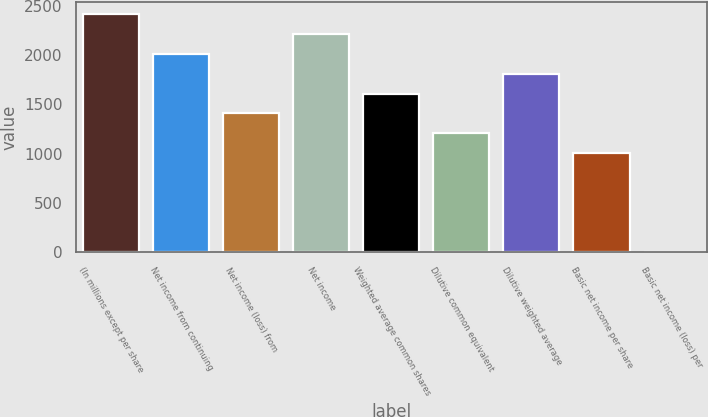Convert chart to OTSL. <chart><loc_0><loc_0><loc_500><loc_500><bar_chart><fcel>(In millions except per share<fcel>Net income from continuing<fcel>Net income (loss) from<fcel>Net income<fcel>Weighted average common shares<fcel>Dilutive common equivalent<fcel>Dilutive weighted average<fcel>Basic net income per share<fcel>Basic net income (loss) per<nl><fcel>2415.53<fcel>2012.97<fcel>1409.13<fcel>2214.25<fcel>1610.41<fcel>1207.85<fcel>1811.69<fcel>1006.57<fcel>0.17<nl></chart> 